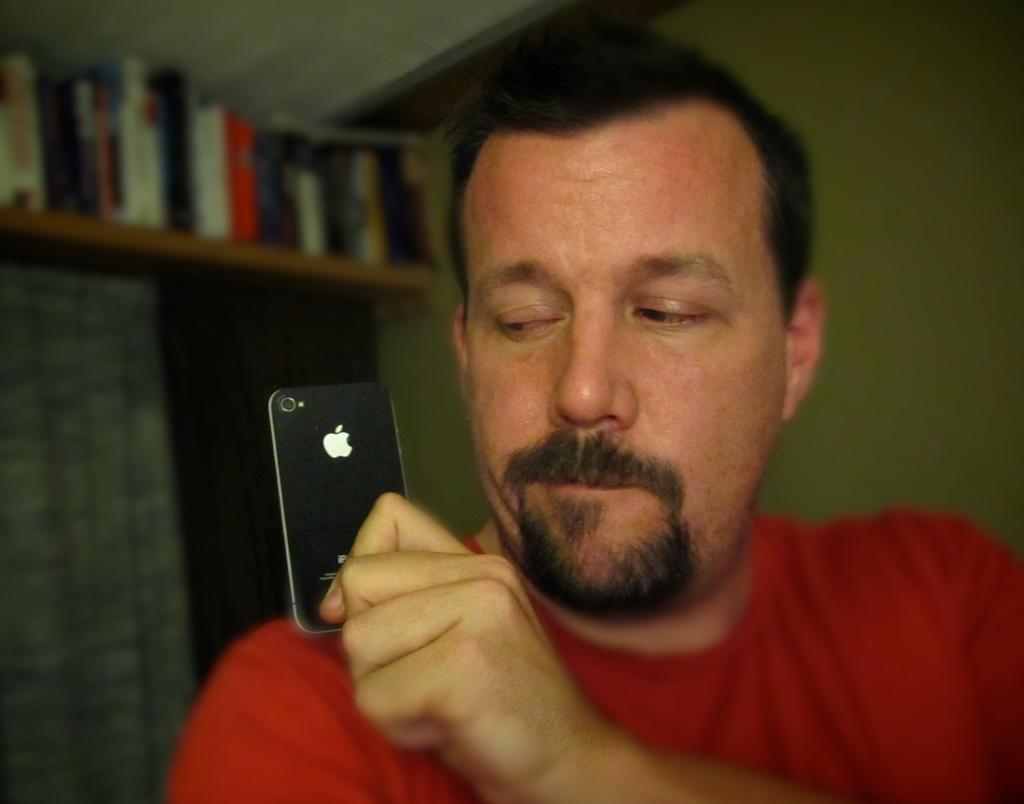Can you describe this image briefly? In this image, There is a man holding a mobile which is in black color, In the background there are some books kept in the shelf and there is a wall which is in white color. 